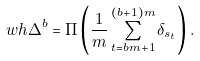<formula> <loc_0><loc_0><loc_500><loc_500>\ w h \Delta ^ { b } = \Pi \left ( \frac { 1 } { m } \sum _ { t = b m + 1 } ^ { ( b + 1 ) m } \delta _ { s _ { t } } \right ) .</formula> 